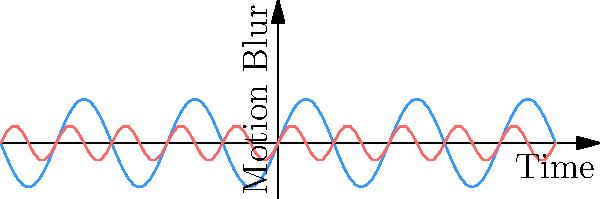Based on the motion blur diagrams for handheld cameras and drones, which statement best describes the image stabilization characteristics of drone-based photography compared to handheld techniques? To answer this question, let's analyze the motion blur diagrams step-by-step:

1. Handheld camera (blue line):
   - Larger amplitude: indicates more significant motion blur
   - Lower frequency: suggests slower, more pronounced movements

2. Drone camera (red line):
   - Smaller amplitude: indicates less motion blur
   - Higher frequency: suggests faster, more subtle vibrations

3. Comparing the two:
   - Drone shows overall less motion blur (smaller amplitude)
   - Drone exhibits higher frequency vibrations, likely due to propeller movements
   - Handheld camera shows more pronounced, slower movements, typical of human hand movements

4. Image stabilization implications:
   - Drones appear to provide better overall stability (less motion blur)
   - However, drones introduce high-frequency vibrations that may require specific stabilization techniques

5. Conclusion:
   Drone-based photography offers improved stability with reduced motion blur compared to handheld techniques, but introduces unique high-frequency vibrations that require specialized stabilization methods.
Answer: Improved stability with high-frequency vibrations 